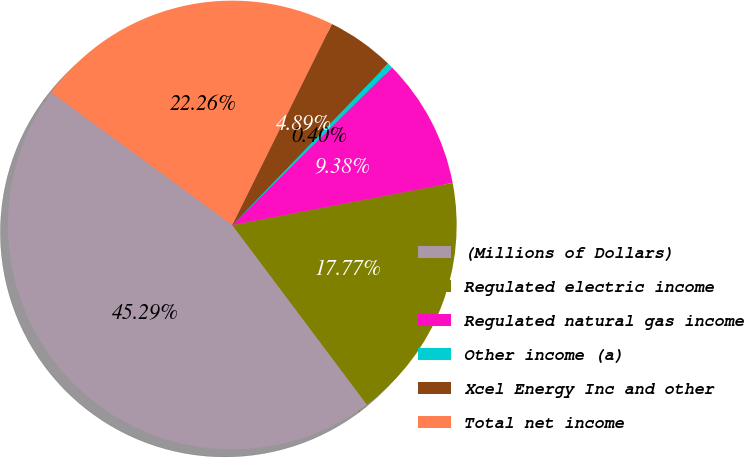Convert chart. <chart><loc_0><loc_0><loc_500><loc_500><pie_chart><fcel>(Millions of Dollars)<fcel>Regulated electric income<fcel>Regulated natural gas income<fcel>Other income (a)<fcel>Xcel Energy Inc and other<fcel>Total net income<nl><fcel>45.29%<fcel>17.77%<fcel>9.38%<fcel>0.4%<fcel>4.89%<fcel>22.26%<nl></chart> 